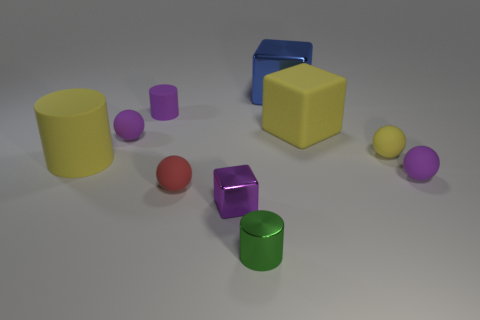Are there fewer purple things that are to the right of the purple shiny block than small gray spheres?
Offer a very short reply. No. Is the shape of the red matte object the same as the small yellow object?
Provide a succinct answer. Yes. There is a yellow rubber object that is left of the green cylinder; what is its size?
Ensure brevity in your answer.  Large. What is the size of the purple cube that is the same material as the tiny green cylinder?
Offer a terse response. Small. Are there fewer small gray balls than tiny metal things?
Provide a succinct answer. Yes. There is a yellow object that is the same size as the red thing; what is its material?
Give a very brief answer. Rubber. Are there more matte cylinders than large green matte cubes?
Ensure brevity in your answer.  Yes. How many other things are the same color as the large shiny thing?
Provide a short and direct response. 0. What number of tiny things are both behind the red rubber thing and in front of the big yellow rubber cylinder?
Keep it short and to the point. 1. Are there any other things that have the same size as the green cylinder?
Your answer should be compact. Yes. 